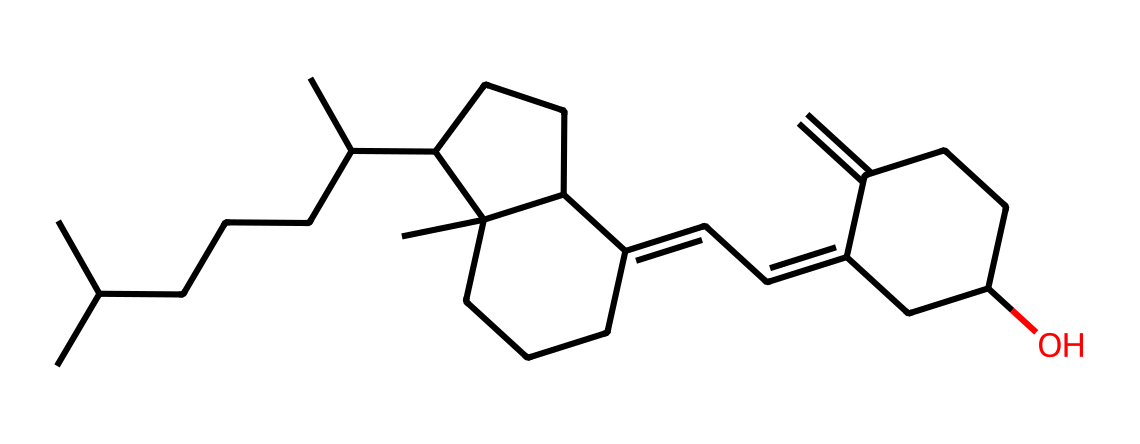How many carbon atoms are present in this vitamin structure? By examining the SMILES representation, we can count the number of carbon atoms indicated by the 'C' letters. Upon analyzing the structure thoroughly, we find there are 27 carbon atoms in total.
Answer: 27 What is the primary function of Vitamin D? Vitamin D is crucial for calcium absorption in the body, which directly impacts bone health. This function is known and recognized in the context of its role in maintaining healthy bones.
Answer: calcium absorption Does this structure contain any hydroxyl groups? Looking at the structure, a hydroxyl group (–OH) is present. We can identify this by the presence of an oxygen atom connected to a carbon atom and a hydrogen atom specifically seen towards the end of the structure.
Answer: yes Is this molecule a vitamin? Based on its structure and identified functional groups, along with its known benefits, it is confirmed that this compound is indeed classified as a vitamin, specifically Vitamin D.
Answer: yes How many rings are present in the structure of Vitamin D? By closely analyzing the cyclic parts of the structure, we can identify three distinct rings that form part of the entire molecule. Thus, the total number of rings in Vitamin D is three.
Answer: 3 What characteristic does Vitamin D provide for musicians, particularly drummers? Vitamin D helps maintain bone strength, which is vital for drummers who rely on good bone health for physical endurance and performance. This association between bone health and drumming highlights the importance of Vitamin D for musicians.
Answer: bone strength 